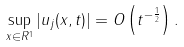<formula> <loc_0><loc_0><loc_500><loc_500>\sup _ { x \in R ^ { 1 } } | u _ { j } ( x , t ) | = O \left ( t ^ { - { \frac { 1 } { 2 } } } \right ) .</formula> 